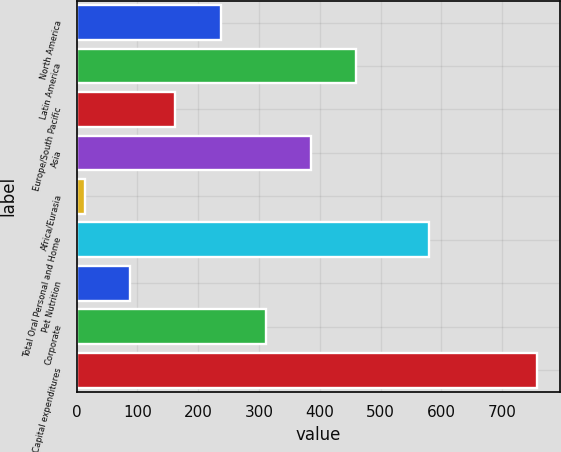<chart> <loc_0><loc_0><loc_500><loc_500><bar_chart><fcel>North America<fcel>Latin America<fcel>Europe/South Pacific<fcel>Asia<fcel>Africa/Eurasia<fcel>Total Oral Personal and Home<fcel>Pet Nutrition<fcel>Corporate<fcel>Total Capital expenditures<nl><fcel>236.9<fcel>459.8<fcel>162.6<fcel>385.5<fcel>14<fcel>580<fcel>88.3<fcel>311.2<fcel>757<nl></chart> 